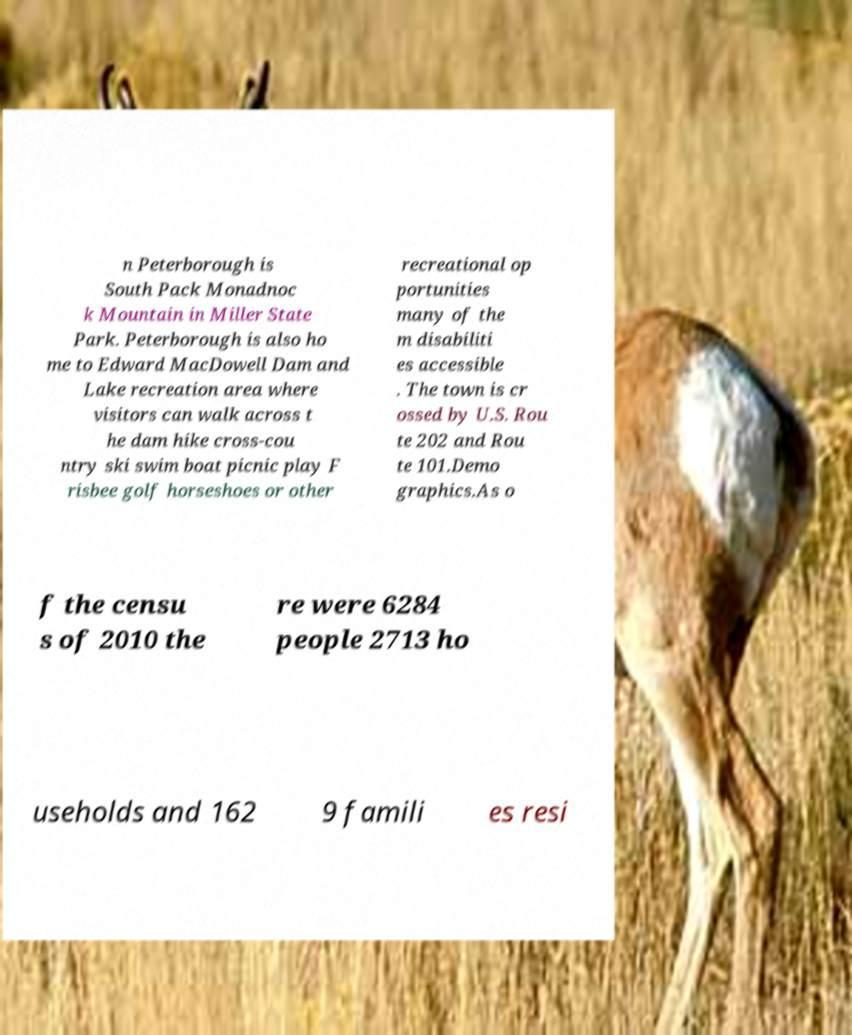Can you read and provide the text displayed in the image?This photo seems to have some interesting text. Can you extract and type it out for me? n Peterborough is South Pack Monadnoc k Mountain in Miller State Park. Peterborough is also ho me to Edward MacDowell Dam and Lake recreation area where visitors can walk across t he dam hike cross-cou ntry ski swim boat picnic play F risbee golf horseshoes or other recreational op portunities many of the m disabiliti es accessible . The town is cr ossed by U.S. Rou te 202 and Rou te 101.Demo graphics.As o f the censu s of 2010 the re were 6284 people 2713 ho useholds and 162 9 famili es resi 